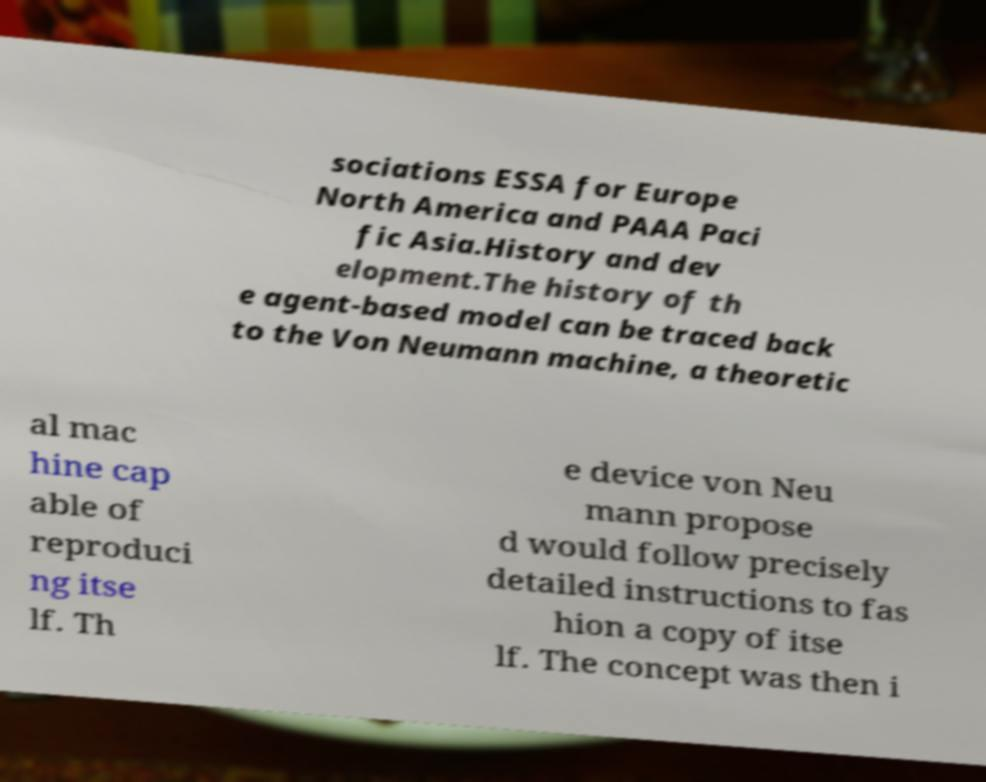Could you extract and type out the text from this image? sociations ESSA for Europe North America and PAAA Paci fic Asia.History and dev elopment.The history of th e agent-based model can be traced back to the Von Neumann machine, a theoretic al mac hine cap able of reproduci ng itse lf. Th e device von Neu mann propose d would follow precisely detailed instructions to fas hion a copy of itse lf. The concept was then i 